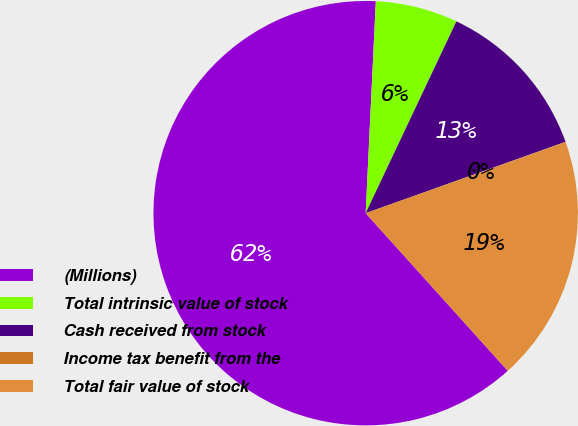Convert chart to OTSL. <chart><loc_0><loc_0><loc_500><loc_500><pie_chart><fcel>(Millions)<fcel>Total intrinsic value of stock<fcel>Cash received from stock<fcel>Income tax benefit from the<fcel>Total fair value of stock<nl><fcel>62.43%<fcel>6.27%<fcel>12.51%<fcel>0.03%<fcel>18.75%<nl></chart> 